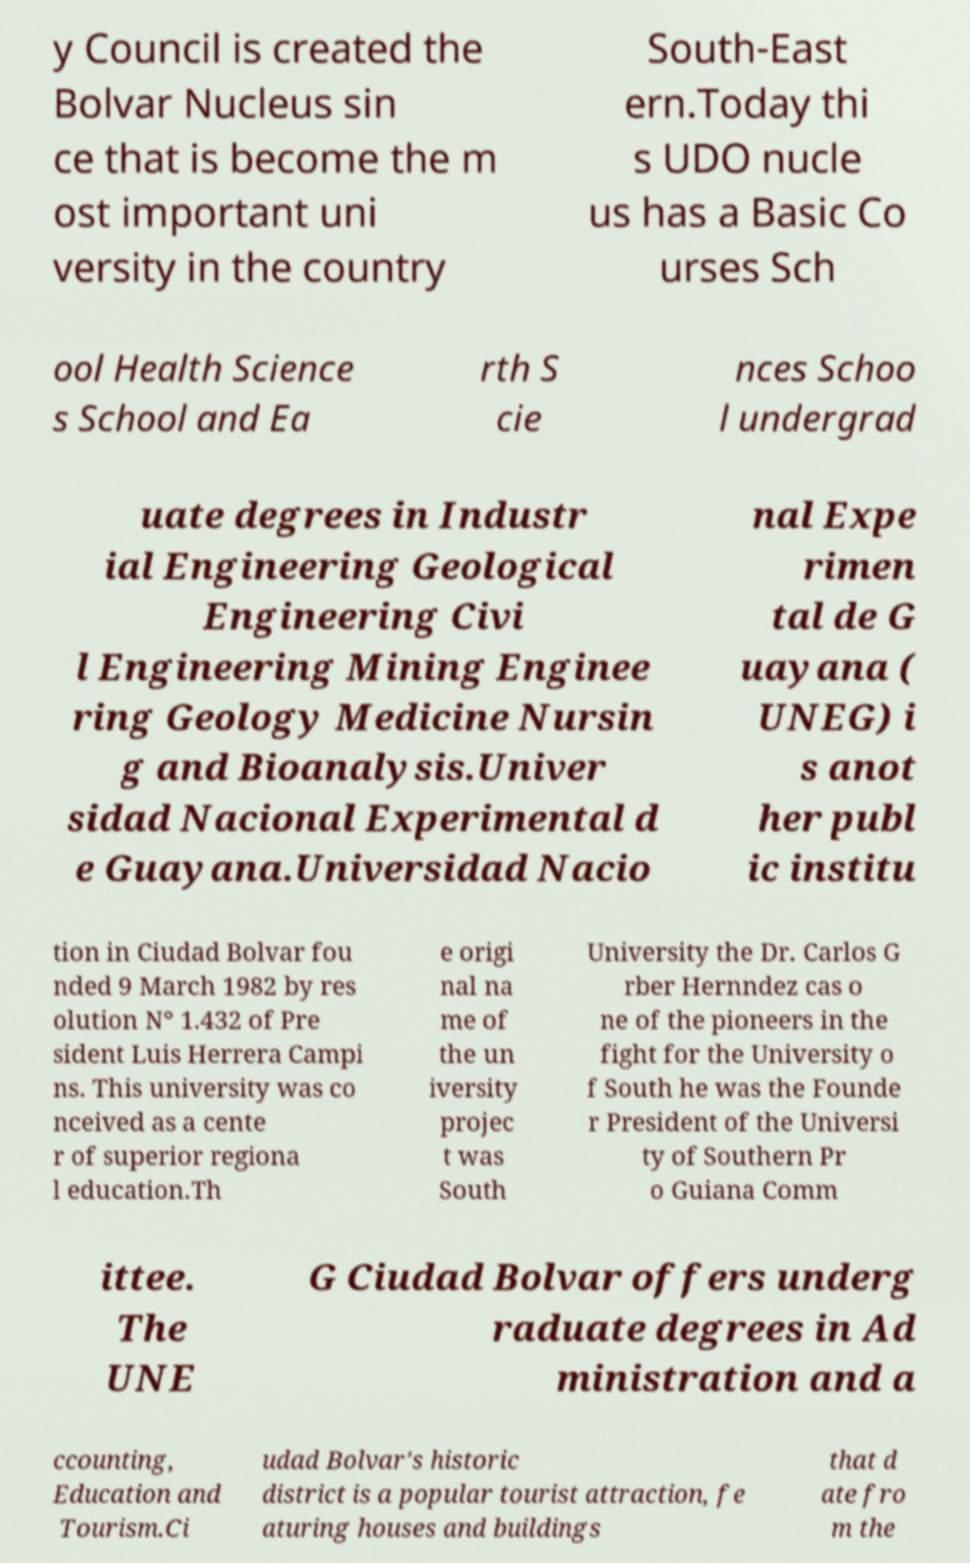Please read and relay the text visible in this image. What does it say? y Council is created the Bolvar Nucleus sin ce that is become the m ost important uni versity in the country South-East ern.Today thi s UDO nucle us has a Basic Co urses Sch ool Health Science s School and Ea rth S cie nces Schoo l undergrad uate degrees in Industr ial Engineering Geological Engineering Civi l Engineering Mining Enginee ring Geology Medicine Nursin g and Bioanalysis.Univer sidad Nacional Experimental d e Guayana.Universidad Nacio nal Expe rimen tal de G uayana ( UNEG) i s anot her publ ic institu tion in Ciudad Bolvar fou nded 9 March 1982 by res olution N° 1.432 of Pre sident Luis Herrera Campi ns. This university was co nceived as a cente r of superior regiona l education.Th e origi nal na me of the un iversity projec t was South University the Dr. Carlos G rber Hernndez cas o ne of the pioneers in the fight for the University o f South he was the Founde r President of the Universi ty of Southern Pr o Guiana Comm ittee. The UNE G Ciudad Bolvar offers underg raduate degrees in Ad ministration and a ccounting, Education and Tourism.Ci udad Bolvar's historic district is a popular tourist attraction, fe aturing houses and buildings that d ate fro m the 